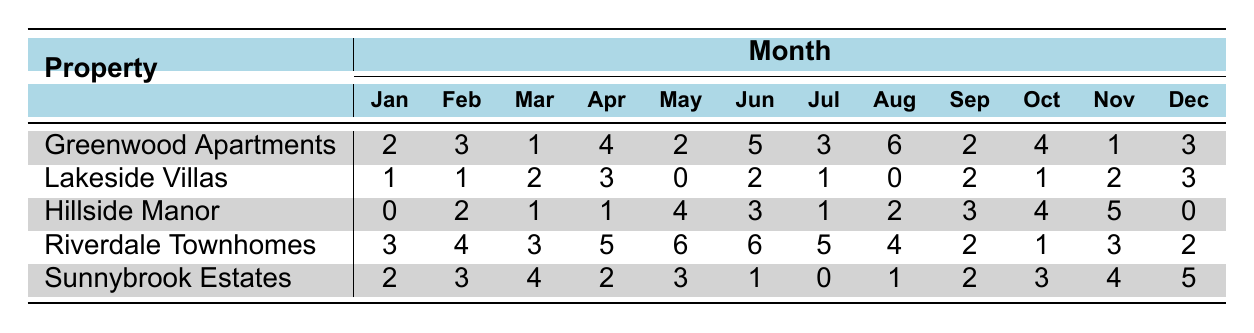What property had the highest number of tenant-reported issues in August? By looking at the August column for each property, Greenwood Apartments reported 6 issues, which is the highest compared to the other properties.
Answer: Greenwood Apartments What was the total number of tenant-reported issues for Lakeside Villas throughout the year? To find the total, sum up the issues reported each month: 1 + 1 + 2 + 3 + 0 + 2 + 1 + 0 + 2 + 1 + 2 + 3 = 18.
Answer: 18 Which property had the fewest issues reported in January? In January, Hillside Manor has 0 issues reported, which is the fewest compared to other properties.
Answer: Hillside Manor For which month did Riverdale Townhomes see the highest number of reported issues? Looking across the months for Riverdale Townhomes, May recorded the highest number of issues reported at 6.
Answer: May What is the average number of tenant-reported issues for Sunnybrook Estates? To calculate the average, sum the reported issues: 2 + 3 + 4 + 2 + 3 + 1 + 0 + 1 + 2 + 3 + 4 + 5 = 26, and then divide by 12 (number of months): 26/12 = 2.17.
Answer: 2.17 Did Hillside Manor report any issues in December? Checking the December column for Hillside Manor, it shows 0 issues reported, confirming that there were no issues reported in that month.
Answer: Yes What is the difference in the number of issues reported between Greenwood Apartments and Riverdale Townhomes in April? In April, Greenwood Apartments reported 4 issues while Riverdale Townhomes reported 5 issues; the difference is 5 - 4 = 1.
Answer: 1 Which property had a consistent increase in tenant-reported issues from January to August? Analyzing the data, it shows that Greenwood Apartments started with 2 in January and increased to 6 in August, depicting a consistent increase throughout those months.
Answer: Greenwood Apartments What was the total number of tenant-reported issues in October for all properties combined? Adding the issues from all properties in October: 4 (Greenwood) + 1 (Lakeside) + 4 (Hillside) + 1 (Riverdale) + 3 (Sunnybrook) = 13.
Answer: 13 Are there any months where Lakeside Villas had no tenant-reported issues? Yes, in May and August, Lakeside Villas reported 0 issues.
Answer: Yes 